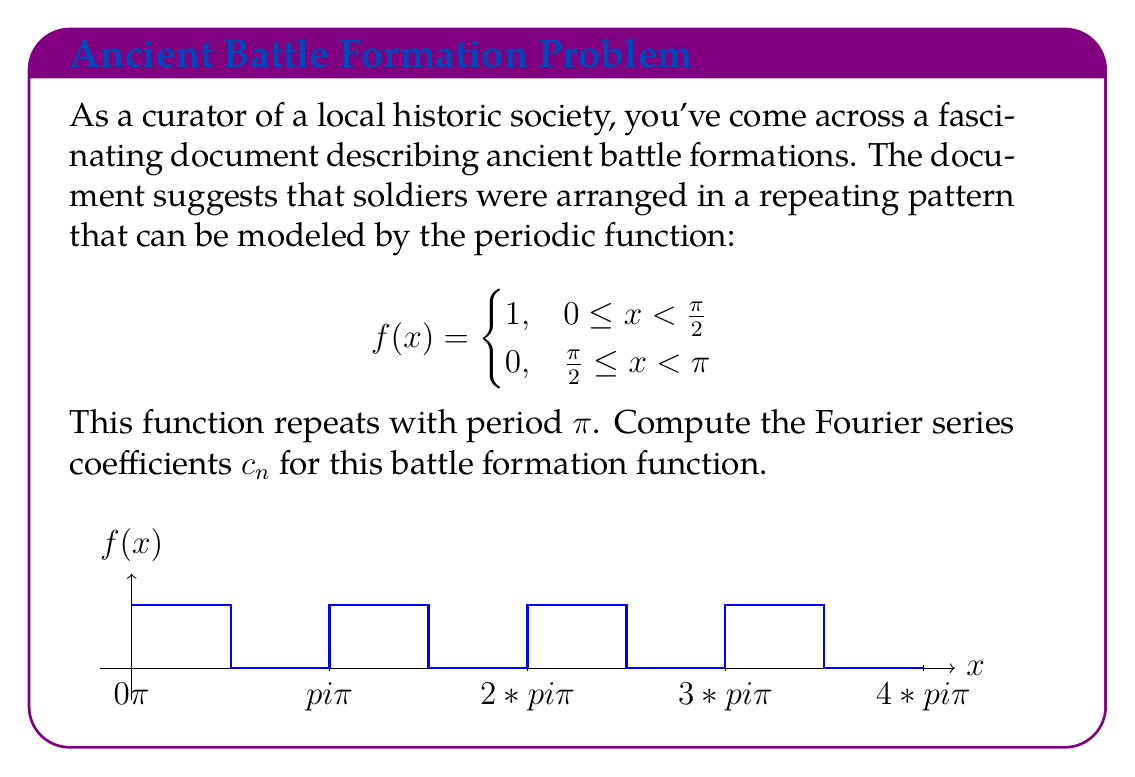Help me with this question. To find the Fourier series coefficients $c_n$, we need to use the formula:

$$c_n = \frac{1}{T} \int_0^T f(x) e^{-i\frac{2\pi nx}{T}} dx$$

Where $T$ is the period of the function, which in this case is $\pi$.

1) First, let's set up our integral:

   $$c_n = \frac{1}{\pi} \int_0^\pi f(x) e^{-i2nx} dx$$

2) We can split this integral into two parts based on the piecewise definition of $f(x)$:

   $$c_n = \frac{1}{\pi} \left(\int_0^{\pi/2} 1 \cdot e^{-i2nx} dx + \int_{\pi/2}^\pi 0 \cdot e^{-i2nx} dx\right)$$

3) The second integral becomes zero, so we're left with:

   $$c_n = \frac{1}{\pi} \int_0^{\pi/2} e^{-i2nx} dx$$

4) Now we can evaluate this integral:

   $$c_n = \frac{1}{\pi} \left[-\frac{1}{i2n}e^{-i2nx}\right]_0^{\pi/2} = \frac{1}{\pi} \left(-\frac{1}{i2n}e^{-in\pi} + \frac{1}{i2n}\right)$$

5) Simplify:

   $$c_n = \frac{1}{2\pi n i} (1 - e^{-in\pi}) = \frac{1}{2\pi n i} (1 - (-1)^n)$$

6) For $n \neq 0$, this simplifies to:

   $$c_n = \begin{cases}
   0, & \text{if } n \text{ is even} \\
   \frac{1}{\pi n i}, & \text{if } n \text{ is odd}
   \end{cases}$$

7) For $n = 0$, we need to calculate separately:

   $$c_0 = \frac{1}{\pi} \int_0^{\pi/2} 1 dx = \frac{1}{2}$$

Thus, we have found all the Fourier coefficients $c_n$.
Answer: $c_n = \begin{cases}
\frac{1}{2}, & n = 0 \\
0, & n \text{ even}, n \neq 0 \\
\frac{1}{\pi n i}, & n \text{ odd}
\end{cases}$ 